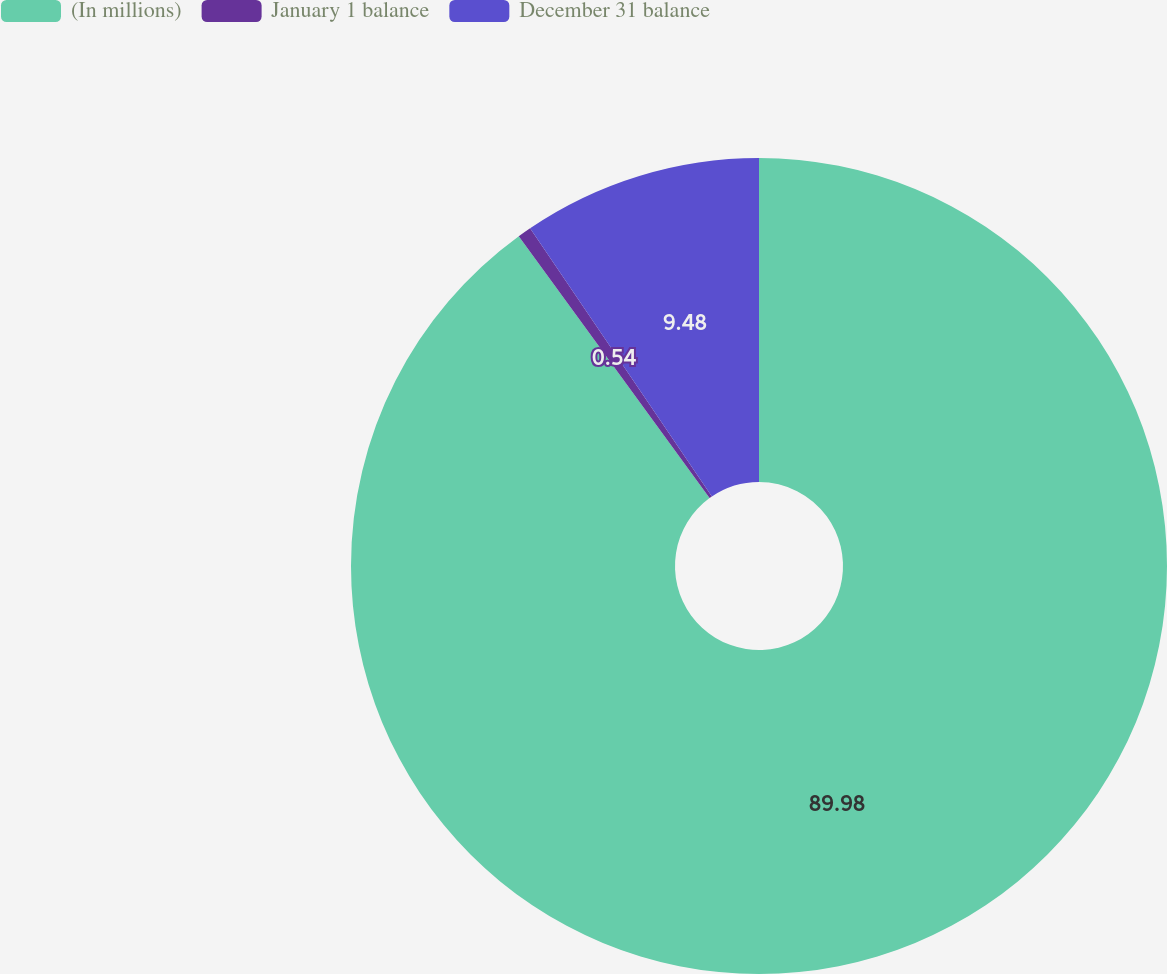<chart> <loc_0><loc_0><loc_500><loc_500><pie_chart><fcel>(In millions)<fcel>January 1 balance<fcel>December 31 balance<nl><fcel>89.98%<fcel>0.54%<fcel>9.48%<nl></chart> 